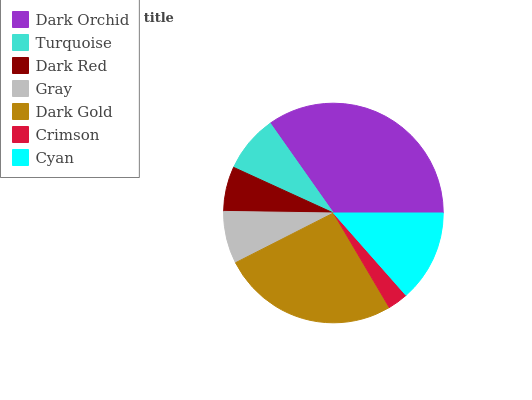Is Crimson the minimum?
Answer yes or no. Yes. Is Dark Orchid the maximum?
Answer yes or no. Yes. Is Turquoise the minimum?
Answer yes or no. No. Is Turquoise the maximum?
Answer yes or no. No. Is Dark Orchid greater than Turquoise?
Answer yes or no. Yes. Is Turquoise less than Dark Orchid?
Answer yes or no. Yes. Is Turquoise greater than Dark Orchid?
Answer yes or no. No. Is Dark Orchid less than Turquoise?
Answer yes or no. No. Is Turquoise the high median?
Answer yes or no. Yes. Is Turquoise the low median?
Answer yes or no. Yes. Is Cyan the high median?
Answer yes or no. No. Is Dark Orchid the low median?
Answer yes or no. No. 